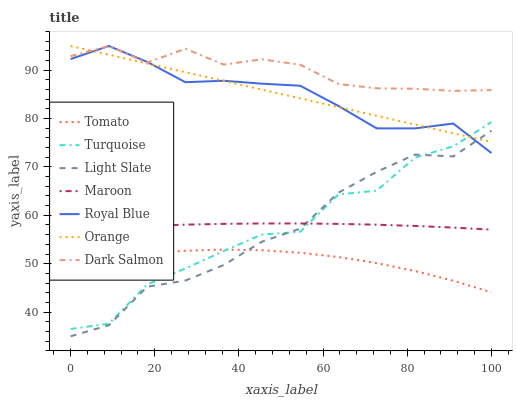Does Tomato have the minimum area under the curve?
Answer yes or no. Yes. Does Dark Salmon have the maximum area under the curve?
Answer yes or no. Yes. Does Turquoise have the minimum area under the curve?
Answer yes or no. No. Does Turquoise have the maximum area under the curve?
Answer yes or no. No. Is Orange the smoothest?
Answer yes or no. Yes. Is Turquoise the roughest?
Answer yes or no. Yes. Is Light Slate the smoothest?
Answer yes or no. No. Is Light Slate the roughest?
Answer yes or no. No. Does Turquoise have the lowest value?
Answer yes or no. No. Does Turquoise have the highest value?
Answer yes or no. No. Is Tomato less than Maroon?
Answer yes or no. Yes. Is Dark Salmon greater than Maroon?
Answer yes or no. Yes. Does Tomato intersect Maroon?
Answer yes or no. No. 